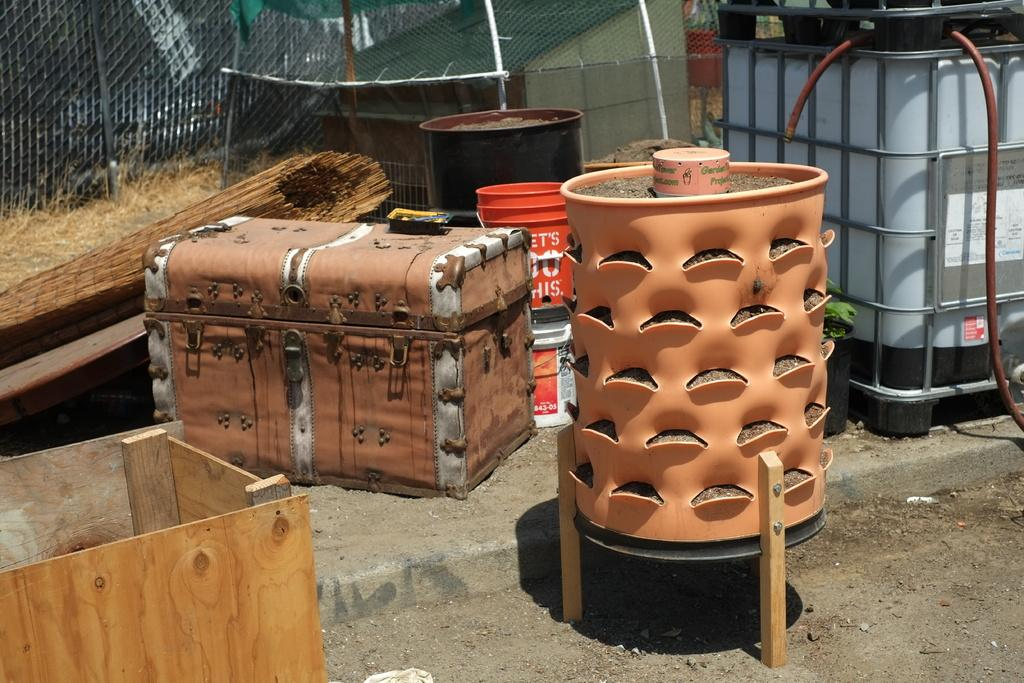What object in the image is typically used for carrying belongings? There is a suitcase in the image, which is typically used for carrying belongings. What object in the image is typically used for holding liquids? There is a bucket in the image, which is typically used for holding liquids. What can be seen in the background of the image? There is a fence in the background of the image. What type of land area is visible at the bottom of the image? The bottom of the image contains a land area with stones. Can you see any mountains in the image? There are no mountains present in the image. Are there any flies visible in the image? There are no flies present in the image. 